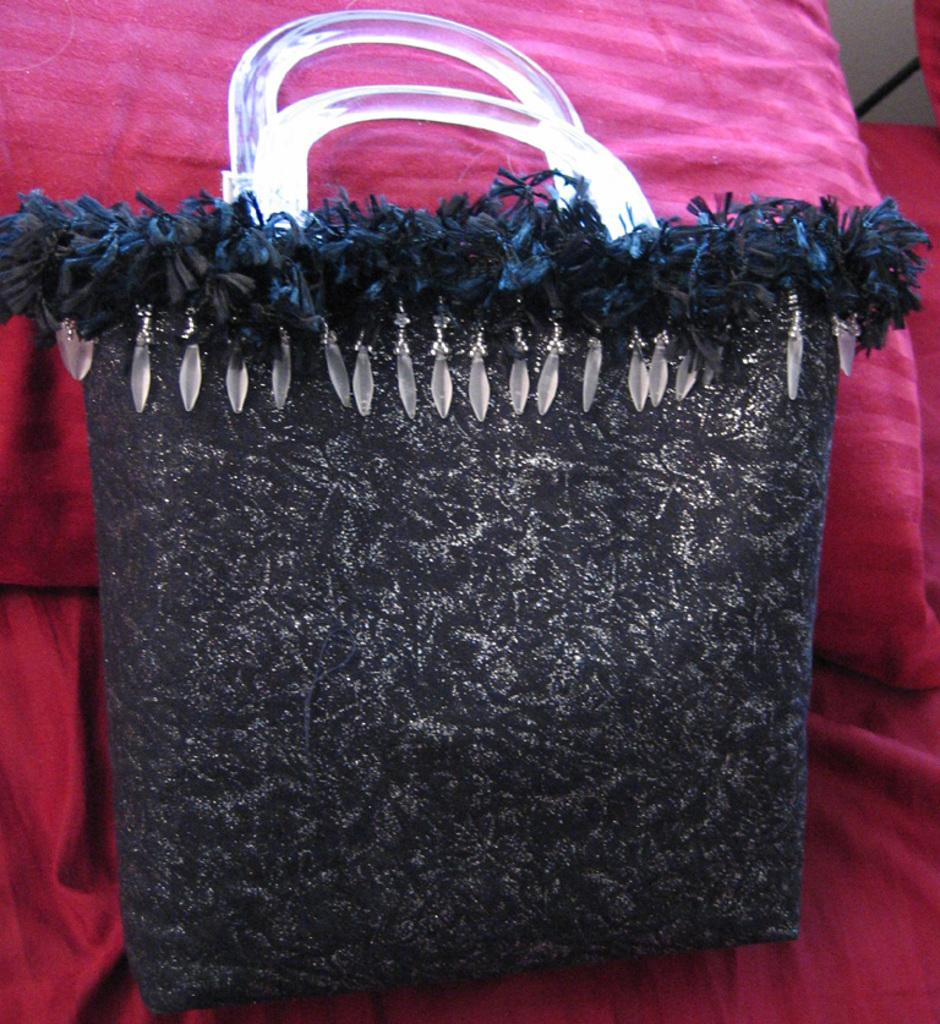What is the color of the handbag in the image? The handbag in the image is black. Where is the handbag placed in the image? The handbag is placed on an object. What can be seen in the background of the image? There is a pillow and other objects visible in the background of the image. How many feathers are attached to the handbag in the image? There are no feathers attached to the handbag in the image. What type of brush is used to clean the pillow in the image? There is no brush or cleaning activity depicted in the image. 